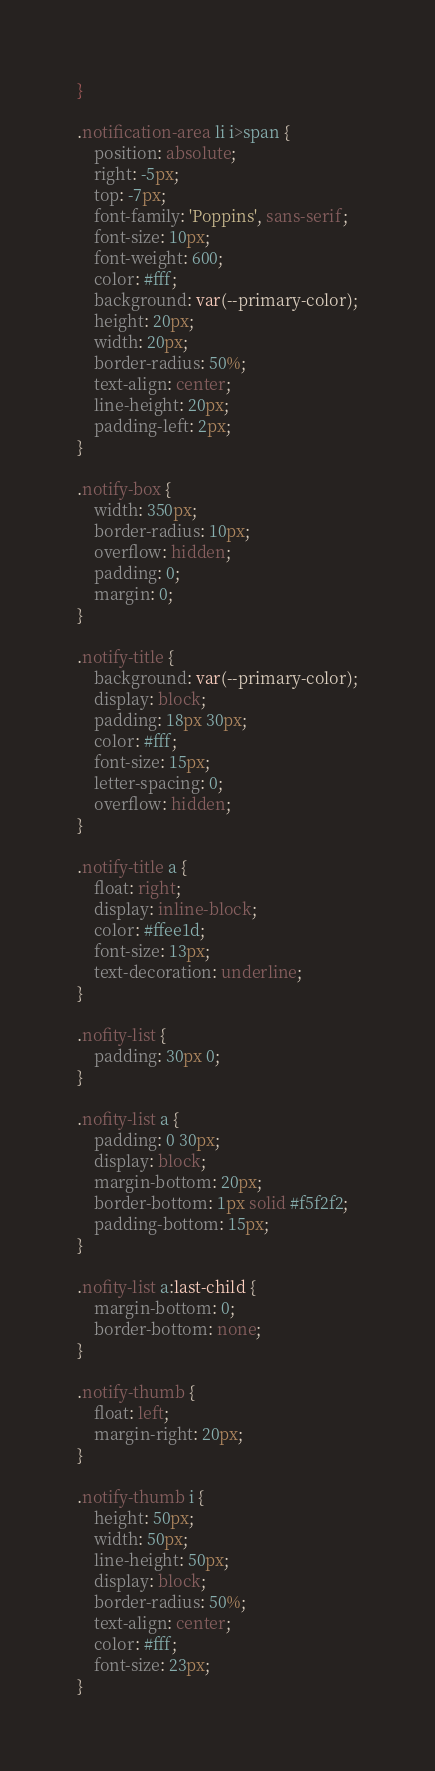<code> <loc_0><loc_0><loc_500><loc_500><_CSS_>}

.notification-area li i>span {
    position: absolute;
    right: -5px;
    top: -7px;
    font-family: 'Poppins', sans-serif;
    font-size: 10px;
    font-weight: 600;
    color: #fff;
    background: var(--primary-color);
    height: 20px;
    width: 20px;
    border-radius: 50%;
    text-align: center;
    line-height: 20px;
    padding-left: 2px;
}

.notify-box {
    width: 350px;
    border-radius: 10px;
    overflow: hidden;
    padding: 0;
    margin: 0;
}

.notify-title {
    background: var(--primary-color);
    display: block;
    padding: 18px 30px;
    color: #fff;
    font-size: 15px;
    letter-spacing: 0;
    overflow: hidden;
}

.notify-title a {
    float: right;
    display: inline-block;
    color: #ffee1d;
    font-size: 13px;
    text-decoration: underline;
}

.nofity-list {
    padding: 30px 0;
}

.nofity-list a {
    padding: 0 30px;
    display: block;
    margin-bottom: 20px;
    border-bottom: 1px solid #f5f2f2;
    padding-bottom: 15px;
}

.nofity-list a:last-child {
    margin-bottom: 0;
    border-bottom: none;
}

.notify-thumb {
    float: left;
    margin-right: 20px;
}

.notify-thumb i {
    height: 50px;
    width: 50px;
    line-height: 50px;
    display: block;
    border-radius: 50%;
    text-align: center;
    color: #fff;
    font-size: 23px;
}
</code> 